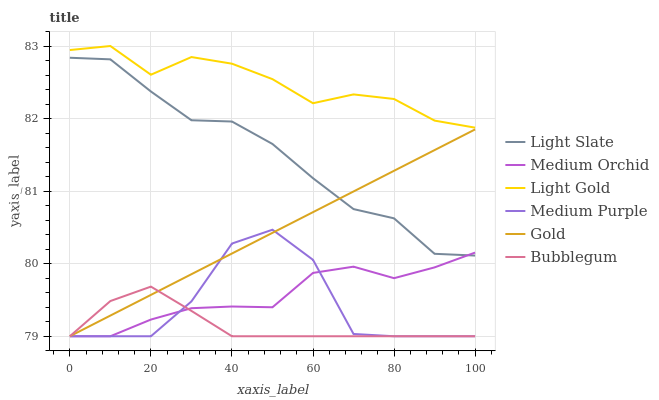Does Bubblegum have the minimum area under the curve?
Answer yes or no. Yes. Does Light Gold have the maximum area under the curve?
Answer yes or no. Yes. Does Light Slate have the minimum area under the curve?
Answer yes or no. No. Does Light Slate have the maximum area under the curve?
Answer yes or no. No. Is Gold the smoothest?
Answer yes or no. Yes. Is Medium Purple the roughest?
Answer yes or no. Yes. Is Light Slate the smoothest?
Answer yes or no. No. Is Light Slate the roughest?
Answer yes or no. No. Does Light Slate have the lowest value?
Answer yes or no. No. Does Light Gold have the highest value?
Answer yes or no. Yes. Does Light Slate have the highest value?
Answer yes or no. No. Is Medium Purple less than Light Gold?
Answer yes or no. Yes. Is Light Gold greater than Gold?
Answer yes or no. Yes. Does Medium Purple intersect Light Gold?
Answer yes or no. No. 